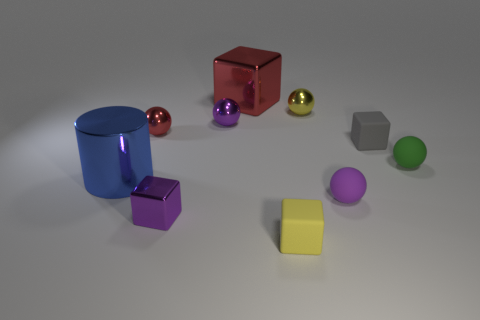What might be the context or setting in which these objects are placed? The objects are arranged in a seemingly random pattern on a flat surface with a neutral background. This setting could be part of a visual study for a 3D modeling project, a setup for a photography light and reflection exercise, or an illustrative display for a geometry lesson. 